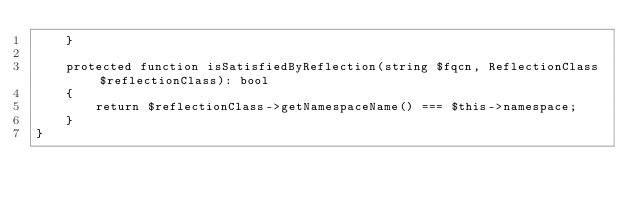<code> <loc_0><loc_0><loc_500><loc_500><_PHP_>    }

    protected function isSatisfiedByReflection(string $fqcn, ReflectionClass $reflectionClass): bool
    {
        return $reflectionClass->getNamespaceName() === $this->namespace;
    }
}
</code> 